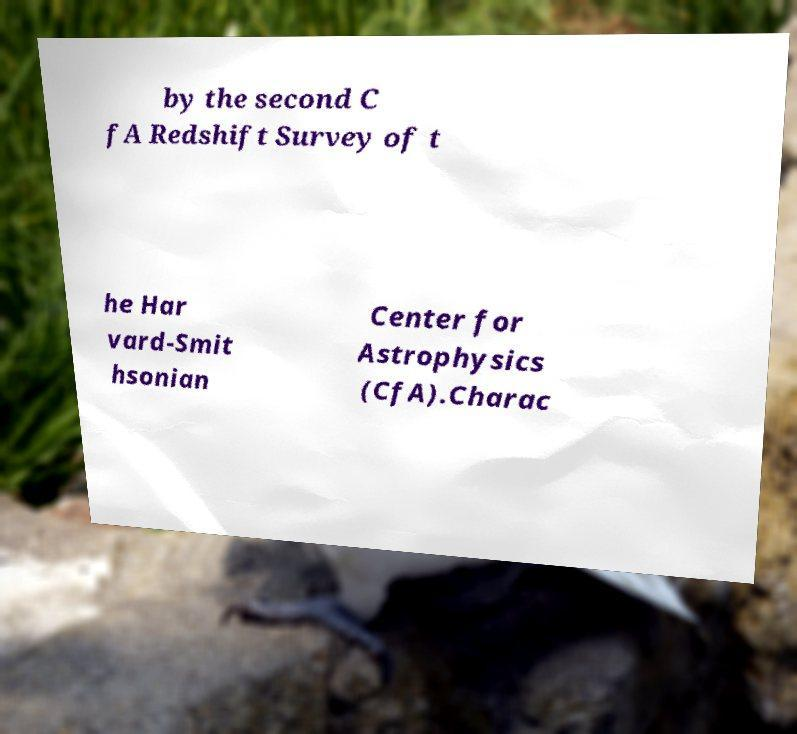Please read and relay the text visible in this image. What does it say? by the second C fA Redshift Survey of t he Har vard-Smit hsonian Center for Astrophysics (CfA).Charac 